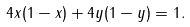Convert formula to latex. <formula><loc_0><loc_0><loc_500><loc_500>4 x ( 1 - x ) + 4 y ( 1 - y ) = 1 .</formula> 